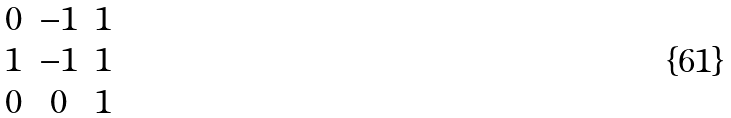<formula> <loc_0><loc_0><loc_500><loc_500>\begin{matrix} 0 & - 1 & 1 \\ 1 & - 1 & 1 \\ 0 & 0 & 1 \end{matrix}</formula> 